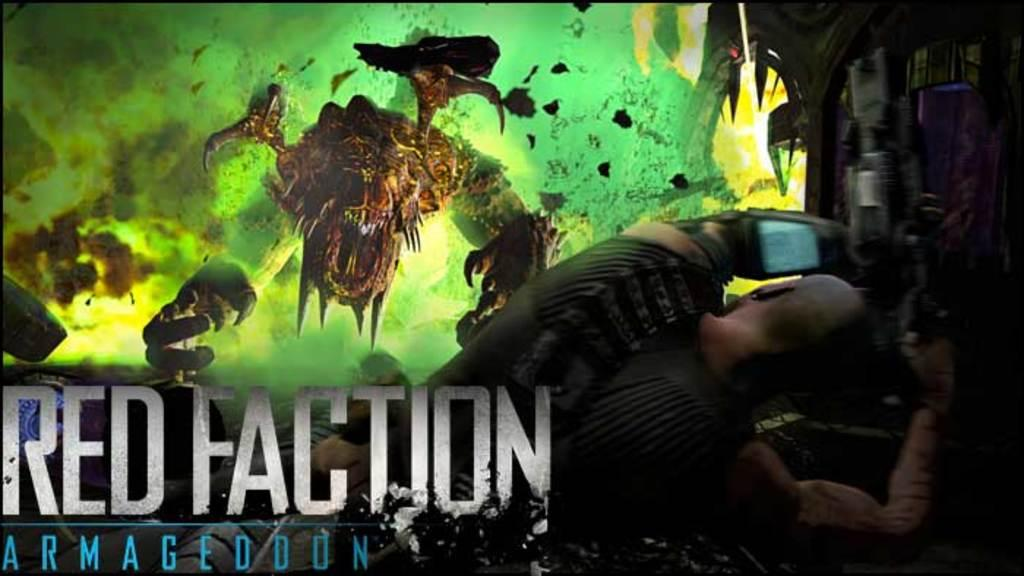What is the main subject of the image? There is a poster in the image. What can be seen on the poster? The poster contains a few other posters, a person, and other objects. Is there any text on the poster? Yes, there is text in the foreground of the poster. What type of squirrel can be seen climbing the store in the image? There is no store or squirrel present in the image. 